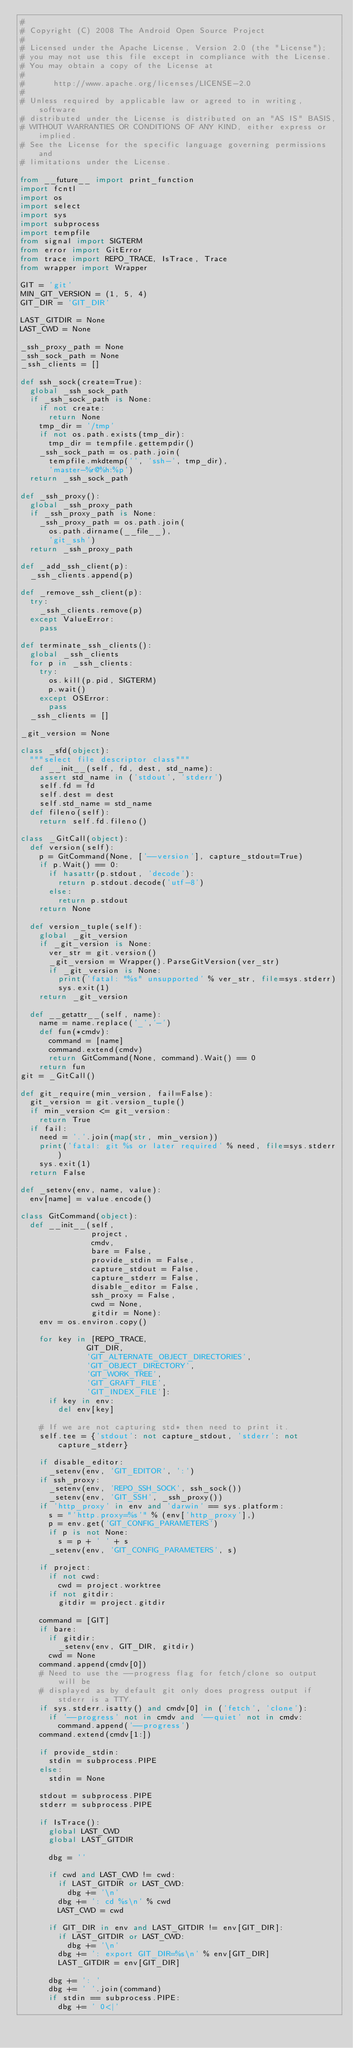<code> <loc_0><loc_0><loc_500><loc_500><_Python_>#
# Copyright (C) 2008 The Android Open Source Project
#
# Licensed under the Apache License, Version 2.0 (the "License");
# you may not use this file except in compliance with the License.
# You may obtain a copy of the License at
#
#      http://www.apache.org/licenses/LICENSE-2.0
#
# Unless required by applicable law or agreed to in writing, software
# distributed under the License is distributed on an "AS IS" BASIS,
# WITHOUT WARRANTIES OR CONDITIONS OF ANY KIND, either express or implied.
# See the License for the specific language governing permissions and
# limitations under the License.

from __future__ import print_function
import fcntl
import os
import select
import sys
import subprocess
import tempfile
from signal import SIGTERM
from error import GitError
from trace import REPO_TRACE, IsTrace, Trace
from wrapper import Wrapper

GIT = 'git'
MIN_GIT_VERSION = (1, 5, 4)
GIT_DIR = 'GIT_DIR'

LAST_GITDIR = None
LAST_CWD = None

_ssh_proxy_path = None
_ssh_sock_path = None
_ssh_clients = []

def ssh_sock(create=True):
  global _ssh_sock_path
  if _ssh_sock_path is None:
    if not create:
      return None
    tmp_dir = '/tmp'
    if not os.path.exists(tmp_dir):
      tmp_dir = tempfile.gettempdir()
    _ssh_sock_path = os.path.join(
      tempfile.mkdtemp('', 'ssh-', tmp_dir),
      'master-%r@%h:%p')
  return _ssh_sock_path

def _ssh_proxy():
  global _ssh_proxy_path
  if _ssh_proxy_path is None:
    _ssh_proxy_path = os.path.join(
      os.path.dirname(__file__),
      'git_ssh')
  return _ssh_proxy_path

def _add_ssh_client(p):
  _ssh_clients.append(p)

def _remove_ssh_client(p):
  try:
    _ssh_clients.remove(p)
  except ValueError:
    pass

def terminate_ssh_clients():
  global _ssh_clients
  for p in _ssh_clients:
    try:
      os.kill(p.pid, SIGTERM)
      p.wait()
    except OSError:
      pass
  _ssh_clients = []

_git_version = None

class _sfd(object):
  """select file descriptor class"""
  def __init__(self, fd, dest, std_name):
    assert std_name in ('stdout', 'stderr')
    self.fd = fd
    self.dest = dest
    self.std_name = std_name
  def fileno(self):
    return self.fd.fileno()

class _GitCall(object):
  def version(self):
    p = GitCommand(None, ['--version'], capture_stdout=True)
    if p.Wait() == 0:
      if hasattr(p.stdout, 'decode'):
        return p.stdout.decode('utf-8')
      else:
        return p.stdout
    return None

  def version_tuple(self):
    global _git_version
    if _git_version is None:
      ver_str = git.version()
      _git_version = Wrapper().ParseGitVersion(ver_str)
      if _git_version is None:
        print('fatal: "%s" unsupported' % ver_str, file=sys.stderr)
        sys.exit(1)
    return _git_version

  def __getattr__(self, name):
    name = name.replace('_','-')
    def fun(*cmdv):
      command = [name]
      command.extend(cmdv)
      return GitCommand(None, command).Wait() == 0
    return fun
git = _GitCall()

def git_require(min_version, fail=False):
  git_version = git.version_tuple()
  if min_version <= git_version:
    return True
  if fail:
    need = '.'.join(map(str, min_version))
    print('fatal: git %s or later required' % need, file=sys.stderr)
    sys.exit(1)
  return False

def _setenv(env, name, value):
  env[name] = value.encode()

class GitCommand(object):
  def __init__(self,
               project,
               cmdv,
               bare = False,
               provide_stdin = False,
               capture_stdout = False,
               capture_stderr = False,
               disable_editor = False,
               ssh_proxy = False,
               cwd = None,
               gitdir = None):
    env = os.environ.copy()

    for key in [REPO_TRACE,
              GIT_DIR,
              'GIT_ALTERNATE_OBJECT_DIRECTORIES',
              'GIT_OBJECT_DIRECTORY',
              'GIT_WORK_TREE',
              'GIT_GRAFT_FILE',
              'GIT_INDEX_FILE']:
      if key in env:
        del env[key]

    # If we are not capturing std* then need to print it.
    self.tee = {'stdout': not capture_stdout, 'stderr': not capture_stderr}

    if disable_editor:
      _setenv(env, 'GIT_EDITOR', ':')
    if ssh_proxy:
      _setenv(env, 'REPO_SSH_SOCK', ssh_sock())
      _setenv(env, 'GIT_SSH', _ssh_proxy())
    if 'http_proxy' in env and 'darwin' == sys.platform:
      s = "'http.proxy=%s'" % (env['http_proxy'],)
      p = env.get('GIT_CONFIG_PARAMETERS')
      if p is not None:
        s = p + ' ' + s
      _setenv(env, 'GIT_CONFIG_PARAMETERS', s)

    if project:
      if not cwd:
        cwd = project.worktree
      if not gitdir:
        gitdir = project.gitdir

    command = [GIT]
    if bare:
      if gitdir:
        _setenv(env, GIT_DIR, gitdir)
      cwd = None
    command.append(cmdv[0])
    # Need to use the --progress flag for fetch/clone so output will be
    # displayed as by default git only does progress output if stderr is a TTY.
    if sys.stderr.isatty() and cmdv[0] in ('fetch', 'clone'):
      if '--progress' not in cmdv and '--quiet' not in cmdv:
        command.append('--progress')
    command.extend(cmdv[1:])

    if provide_stdin:
      stdin = subprocess.PIPE
    else:
      stdin = None

    stdout = subprocess.PIPE
    stderr = subprocess.PIPE

    if IsTrace():
      global LAST_CWD
      global LAST_GITDIR

      dbg = ''

      if cwd and LAST_CWD != cwd:
        if LAST_GITDIR or LAST_CWD:
          dbg += '\n'
        dbg += ': cd %s\n' % cwd
        LAST_CWD = cwd

      if GIT_DIR in env and LAST_GITDIR != env[GIT_DIR]:
        if LAST_GITDIR or LAST_CWD:
          dbg += '\n'
        dbg += ': export GIT_DIR=%s\n' % env[GIT_DIR]
        LAST_GITDIR = env[GIT_DIR]

      dbg += ': '
      dbg += ' '.join(command)
      if stdin == subprocess.PIPE:
        dbg += ' 0<|'</code> 